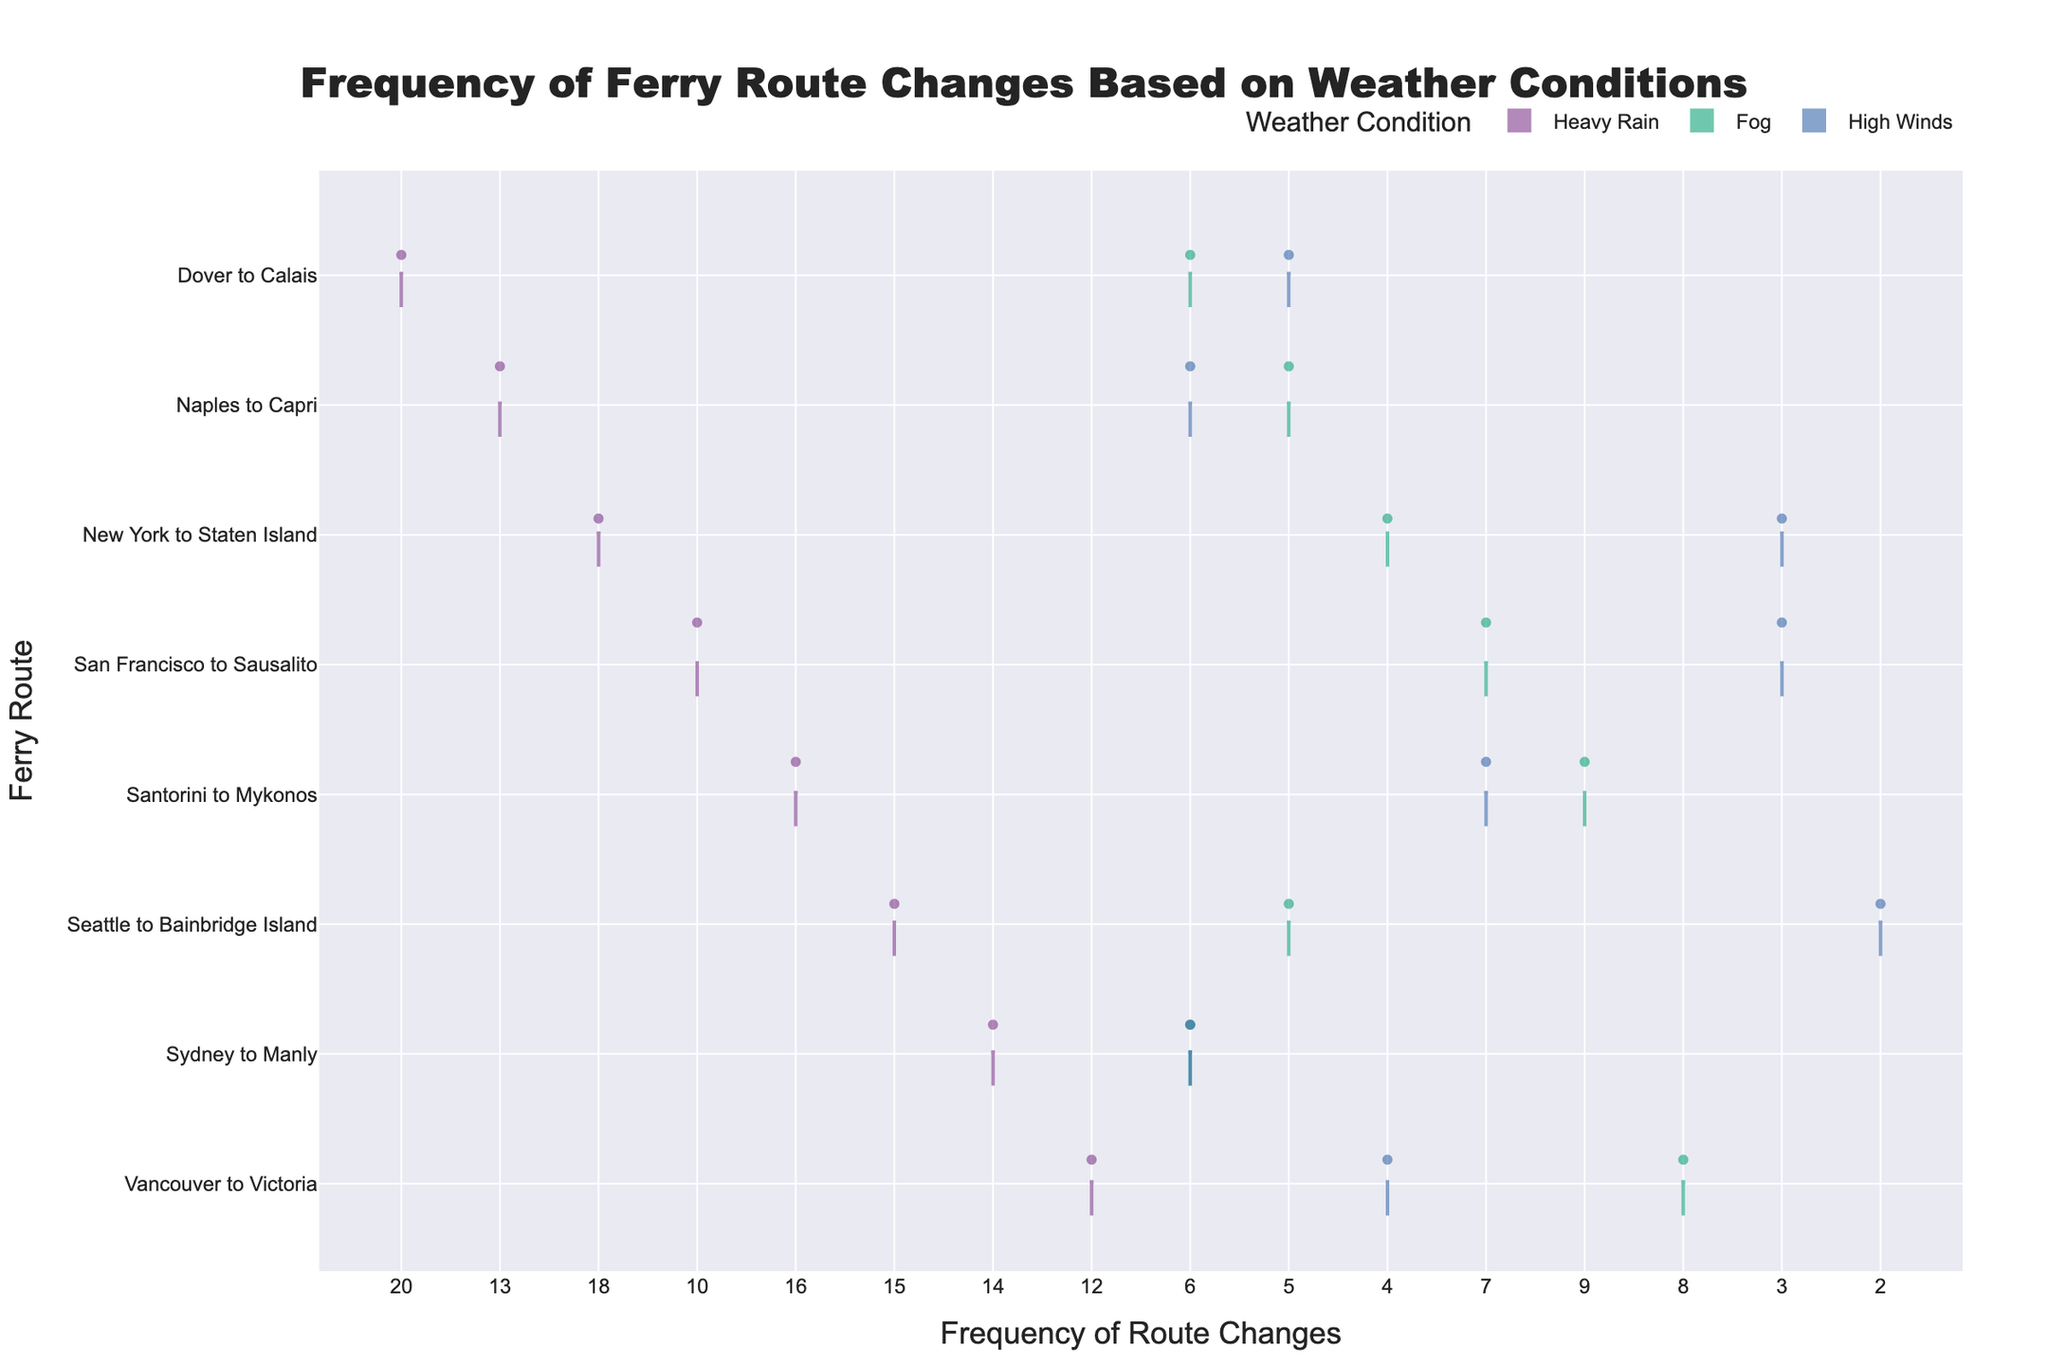What is the highest frequency of ferry route changes for "Dover to Calais"? Examine the half-violins for the "Dover to Calais" route across all weather conditions (Heavy Rain, Fog, High Winds). The highest point on the frequency axis for this route corresponds to Heavy Rain with a value of 20.
Answer: 20 For which weather condition does the "Sydney to Manly" route have the lowest frequency of changes? Observe the "Sydney to Manly" route on the y-axis. The lowest frequency of changes occurs under Fog and High Winds, with frequencies both being 6.
Answer: Fog and High Winds Between "Seattle to Bainbridge Island" and "San Francisco to Sausalito," which ferry route experiences more frequent changes under Fog? Compare the violin plots for both routes under the Fog condition. "San Francisco to Sausalito" has a higher frequency of 7 compared to "Seattle to Bainbridge Island" with a frequency of 5.
Answer: San Francisco to Sausalito Which ferry route has the most balanced distribution of frequency changes across all weather conditions? Look for the route with similar violin plot shapes and areas across Heavy Rain, Fog, and High Winds. "Sydney to Manly" has relatively balanced frequencies with 14, 6, and 6 across the conditions.
Answer: Sydney to Manly What is the median frequency of ferry route changes for "New York to Staten Island" under Heavy Rain? Check the median line in the Heavy Rain violin for "New York to Staten Island." It aligns closest with the frequency value, which is around 18.
Answer: 18 Which weather condition generally causes the highest frequency of ferry route changes across all routes? Review the overall heights of the half-violins for each weather condition. Heavy Rain visibly exhibits the highest frequencies across most routes.
Answer: Heavy Rain How does the "Vancouver to Victoria" route fare in terms of frequency changes when comparing Heavy Rain and Fog? Compare the frequencies for "Vancouver to Victoria" between Heavy Rain (12) and Fog (8). The frequency under Heavy Rain is higher.
Answer: Heavy Rain Which route shows the widest range of variations in frequency changes under High Winds? Assess the spread of the violin plots for routes under High Winds. "Santorini to Mykonos" shows a wider range with a frequency spread up to 7.
Answer: Santorini to Mykonos If you want to minimize disruptions under all weather conditions, which ferry route would be the most reliable based on this chart? Look at the overall lowest frequencies across all weather conditions. "Seattle to Bainbridge Island" shows consistently lower frequencies (15, 5, 2).
Answer: Seattle to Bainbridge Island 